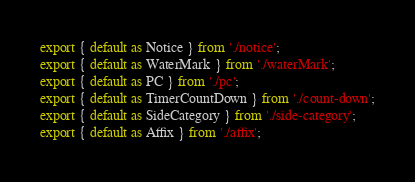Convert code to text. <code><loc_0><loc_0><loc_500><loc_500><_TypeScript_>export { default as Notice } from './notice';
export { default as WaterMark } from './waterMark';
export { default as PC } from './pc';
export { default as TimerCountDown } from './count-down';
export { default as SideCategory } from './side-category';
export { default as Affix } from './affix';
</code> 